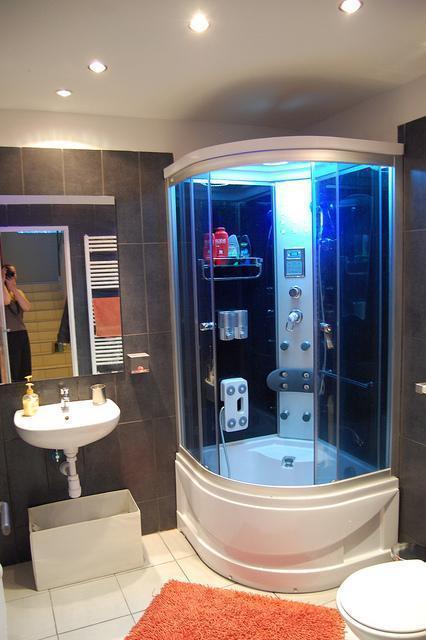What might a person do inside the blue lit area?
From the following set of four choices, select the accurate answer to respond to the question.
Options: Shower, text, cook, rest. Shower. 